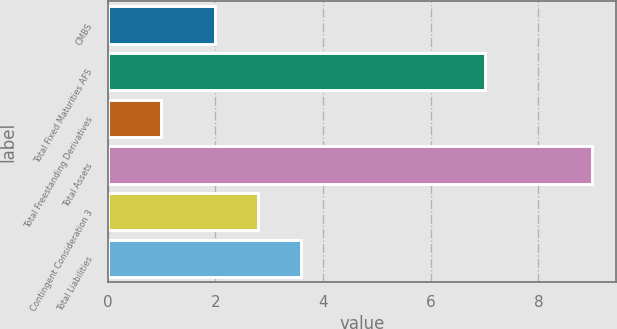Convert chart to OTSL. <chart><loc_0><loc_0><loc_500><loc_500><bar_chart><fcel>CMBS<fcel>Total Fixed Maturities AFS<fcel>Total Freestanding Derivatives<fcel>Total Assets<fcel>Contingent Consideration 3<fcel>Total Liabilities<nl><fcel>2<fcel>7<fcel>1<fcel>9<fcel>2.8<fcel>3.6<nl></chart> 